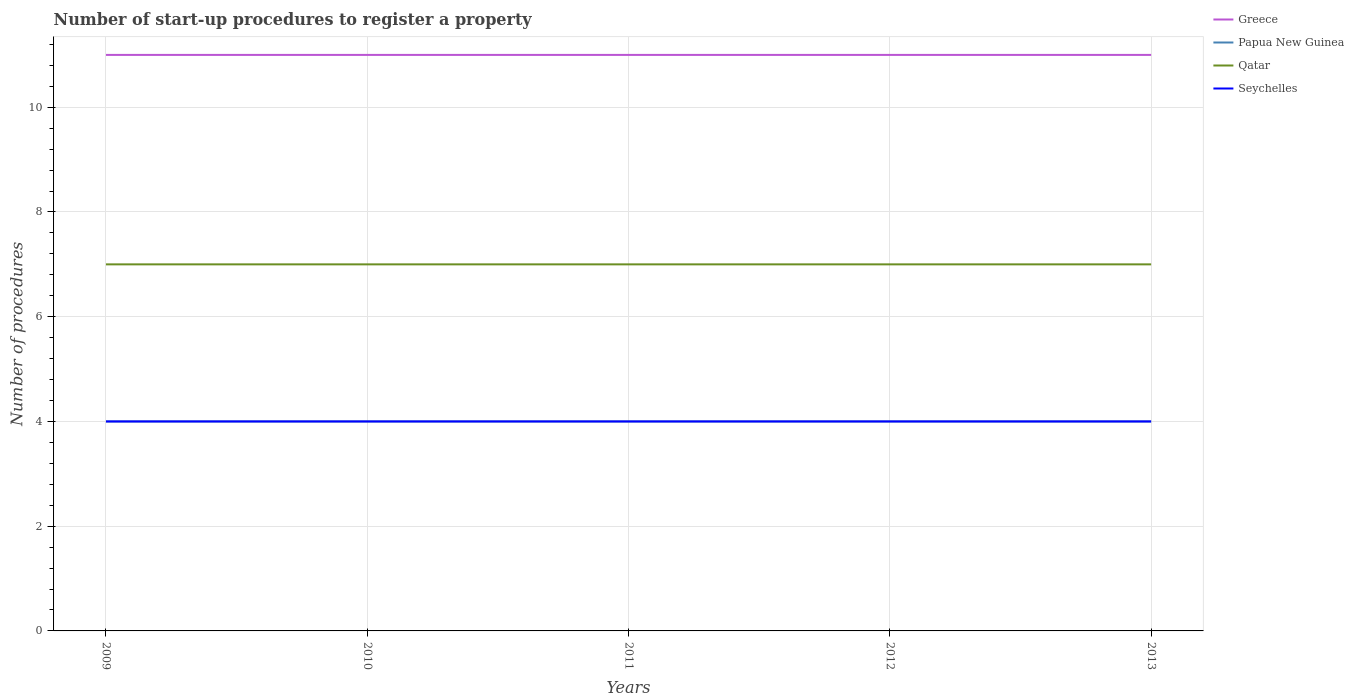Does the line corresponding to Greece intersect with the line corresponding to Seychelles?
Your answer should be very brief. No. Is the number of lines equal to the number of legend labels?
Your response must be concise. Yes. Across all years, what is the maximum number of procedures required to register a property in Papua New Guinea?
Your response must be concise. 4. In which year was the number of procedures required to register a property in Greece maximum?
Your answer should be very brief. 2009. What is the difference between the highest and the second highest number of procedures required to register a property in Seychelles?
Your answer should be very brief. 0. What is the difference between the highest and the lowest number of procedures required to register a property in Papua New Guinea?
Your answer should be very brief. 0. Is the number of procedures required to register a property in Seychelles strictly greater than the number of procedures required to register a property in Greece over the years?
Offer a terse response. Yes. How many lines are there?
Give a very brief answer. 4. How many years are there in the graph?
Your answer should be very brief. 5. What is the difference between two consecutive major ticks on the Y-axis?
Ensure brevity in your answer.  2. Are the values on the major ticks of Y-axis written in scientific E-notation?
Give a very brief answer. No. Where does the legend appear in the graph?
Make the answer very short. Top right. How many legend labels are there?
Your answer should be compact. 4. How are the legend labels stacked?
Offer a terse response. Vertical. What is the title of the graph?
Your answer should be very brief. Number of start-up procedures to register a property. What is the label or title of the X-axis?
Ensure brevity in your answer.  Years. What is the label or title of the Y-axis?
Provide a short and direct response. Number of procedures. What is the Number of procedures of Greece in 2009?
Make the answer very short. 11. What is the Number of procedures of Papua New Guinea in 2009?
Offer a terse response. 4. What is the Number of procedures in Seychelles in 2009?
Offer a terse response. 4. What is the Number of procedures in Qatar in 2010?
Keep it short and to the point. 7. What is the Number of procedures of Greece in 2011?
Provide a succinct answer. 11. What is the Number of procedures in Qatar in 2011?
Your answer should be very brief. 7. What is the Number of procedures in Seychelles in 2011?
Ensure brevity in your answer.  4. What is the Number of procedures in Papua New Guinea in 2012?
Offer a very short reply. 4. What is the Number of procedures in Seychelles in 2012?
Offer a very short reply. 4. What is the Number of procedures of Greece in 2013?
Your answer should be compact. 11. What is the Number of procedures of Qatar in 2013?
Your response must be concise. 7. Across all years, what is the maximum Number of procedures in Greece?
Make the answer very short. 11. Across all years, what is the maximum Number of procedures in Qatar?
Keep it short and to the point. 7. What is the total Number of procedures in Papua New Guinea in the graph?
Offer a very short reply. 20. What is the total Number of procedures in Qatar in the graph?
Offer a very short reply. 35. What is the difference between the Number of procedures of Greece in 2009 and that in 2010?
Offer a terse response. 0. What is the difference between the Number of procedures of Papua New Guinea in 2009 and that in 2010?
Ensure brevity in your answer.  0. What is the difference between the Number of procedures in Seychelles in 2009 and that in 2010?
Offer a terse response. 0. What is the difference between the Number of procedures of Greece in 2009 and that in 2011?
Give a very brief answer. 0. What is the difference between the Number of procedures in Qatar in 2009 and that in 2011?
Your answer should be compact. 0. What is the difference between the Number of procedures of Seychelles in 2009 and that in 2011?
Ensure brevity in your answer.  0. What is the difference between the Number of procedures of Qatar in 2009 and that in 2012?
Offer a very short reply. 0. What is the difference between the Number of procedures in Greece in 2009 and that in 2013?
Make the answer very short. 0. What is the difference between the Number of procedures in Papua New Guinea in 2009 and that in 2013?
Offer a terse response. 0. What is the difference between the Number of procedures of Qatar in 2010 and that in 2011?
Your response must be concise. 0. What is the difference between the Number of procedures in Seychelles in 2010 and that in 2011?
Provide a short and direct response. 0. What is the difference between the Number of procedures in Greece in 2010 and that in 2012?
Your answer should be very brief. 0. What is the difference between the Number of procedures in Papua New Guinea in 2010 and that in 2012?
Make the answer very short. 0. What is the difference between the Number of procedures in Qatar in 2010 and that in 2012?
Ensure brevity in your answer.  0. What is the difference between the Number of procedures in Seychelles in 2010 and that in 2012?
Offer a very short reply. 0. What is the difference between the Number of procedures in Qatar in 2010 and that in 2013?
Your answer should be very brief. 0. What is the difference between the Number of procedures of Seychelles in 2010 and that in 2013?
Your answer should be compact. 0. What is the difference between the Number of procedures in Papua New Guinea in 2011 and that in 2012?
Provide a succinct answer. 0. What is the difference between the Number of procedures of Qatar in 2011 and that in 2012?
Your response must be concise. 0. What is the difference between the Number of procedures of Seychelles in 2011 and that in 2012?
Provide a succinct answer. 0. What is the difference between the Number of procedures in Qatar in 2011 and that in 2013?
Give a very brief answer. 0. What is the difference between the Number of procedures in Papua New Guinea in 2012 and that in 2013?
Provide a succinct answer. 0. What is the difference between the Number of procedures in Greece in 2009 and the Number of procedures in Papua New Guinea in 2010?
Give a very brief answer. 7. What is the difference between the Number of procedures of Greece in 2009 and the Number of procedures of Qatar in 2010?
Make the answer very short. 4. What is the difference between the Number of procedures of Papua New Guinea in 2009 and the Number of procedures of Seychelles in 2010?
Offer a very short reply. 0. What is the difference between the Number of procedures in Greece in 2009 and the Number of procedures in Qatar in 2011?
Provide a succinct answer. 4. What is the difference between the Number of procedures of Qatar in 2009 and the Number of procedures of Seychelles in 2011?
Offer a terse response. 3. What is the difference between the Number of procedures of Greece in 2009 and the Number of procedures of Qatar in 2012?
Provide a succinct answer. 4. What is the difference between the Number of procedures in Papua New Guinea in 2009 and the Number of procedures in Seychelles in 2012?
Your response must be concise. 0. What is the difference between the Number of procedures in Qatar in 2009 and the Number of procedures in Seychelles in 2012?
Make the answer very short. 3. What is the difference between the Number of procedures in Greece in 2010 and the Number of procedures in Papua New Guinea in 2011?
Your answer should be compact. 7. What is the difference between the Number of procedures of Papua New Guinea in 2010 and the Number of procedures of Qatar in 2011?
Your answer should be compact. -3. What is the difference between the Number of procedures of Qatar in 2010 and the Number of procedures of Seychelles in 2011?
Your answer should be very brief. 3. What is the difference between the Number of procedures of Greece in 2010 and the Number of procedures of Papua New Guinea in 2012?
Keep it short and to the point. 7. What is the difference between the Number of procedures in Greece in 2010 and the Number of procedures in Seychelles in 2012?
Make the answer very short. 7. What is the difference between the Number of procedures of Papua New Guinea in 2010 and the Number of procedures of Qatar in 2012?
Offer a terse response. -3. What is the difference between the Number of procedures in Greece in 2010 and the Number of procedures in Papua New Guinea in 2013?
Provide a succinct answer. 7. What is the difference between the Number of procedures of Greece in 2010 and the Number of procedures of Qatar in 2013?
Offer a very short reply. 4. What is the difference between the Number of procedures of Greece in 2010 and the Number of procedures of Seychelles in 2013?
Your answer should be very brief. 7. What is the difference between the Number of procedures in Greece in 2011 and the Number of procedures in Qatar in 2012?
Give a very brief answer. 4. What is the difference between the Number of procedures in Greece in 2011 and the Number of procedures in Seychelles in 2012?
Your answer should be compact. 7. What is the difference between the Number of procedures in Papua New Guinea in 2011 and the Number of procedures in Qatar in 2012?
Offer a very short reply. -3. What is the difference between the Number of procedures of Qatar in 2011 and the Number of procedures of Seychelles in 2012?
Your answer should be compact. 3. What is the difference between the Number of procedures of Greece in 2011 and the Number of procedures of Papua New Guinea in 2013?
Ensure brevity in your answer.  7. What is the difference between the Number of procedures of Papua New Guinea in 2011 and the Number of procedures of Qatar in 2013?
Make the answer very short. -3. What is the difference between the Number of procedures of Papua New Guinea in 2011 and the Number of procedures of Seychelles in 2013?
Ensure brevity in your answer.  0. What is the difference between the Number of procedures of Qatar in 2011 and the Number of procedures of Seychelles in 2013?
Offer a terse response. 3. What is the difference between the Number of procedures in Greece in 2012 and the Number of procedures in Qatar in 2013?
Make the answer very short. 4. What is the difference between the Number of procedures in Greece in 2012 and the Number of procedures in Seychelles in 2013?
Give a very brief answer. 7. What is the difference between the Number of procedures in Qatar in 2012 and the Number of procedures in Seychelles in 2013?
Make the answer very short. 3. What is the average Number of procedures in Papua New Guinea per year?
Ensure brevity in your answer.  4. What is the average Number of procedures of Seychelles per year?
Your answer should be very brief. 4. In the year 2009, what is the difference between the Number of procedures of Greece and Number of procedures of Papua New Guinea?
Provide a succinct answer. 7. In the year 2009, what is the difference between the Number of procedures in Greece and Number of procedures in Qatar?
Your answer should be compact. 4. In the year 2009, what is the difference between the Number of procedures of Greece and Number of procedures of Seychelles?
Provide a short and direct response. 7. In the year 2009, what is the difference between the Number of procedures of Papua New Guinea and Number of procedures of Qatar?
Provide a short and direct response. -3. In the year 2009, what is the difference between the Number of procedures in Papua New Guinea and Number of procedures in Seychelles?
Your response must be concise. 0. In the year 2010, what is the difference between the Number of procedures of Greece and Number of procedures of Papua New Guinea?
Your answer should be compact. 7. In the year 2010, what is the difference between the Number of procedures of Greece and Number of procedures of Seychelles?
Give a very brief answer. 7. In the year 2010, what is the difference between the Number of procedures in Papua New Guinea and Number of procedures in Qatar?
Provide a succinct answer. -3. In the year 2010, what is the difference between the Number of procedures of Qatar and Number of procedures of Seychelles?
Your answer should be very brief. 3. In the year 2011, what is the difference between the Number of procedures of Greece and Number of procedures of Seychelles?
Ensure brevity in your answer.  7. In the year 2011, what is the difference between the Number of procedures of Papua New Guinea and Number of procedures of Seychelles?
Your answer should be compact. 0. In the year 2012, what is the difference between the Number of procedures of Greece and Number of procedures of Papua New Guinea?
Your response must be concise. 7. In the year 2012, what is the difference between the Number of procedures in Greece and Number of procedures in Qatar?
Offer a terse response. 4. In the year 2012, what is the difference between the Number of procedures in Papua New Guinea and Number of procedures in Seychelles?
Give a very brief answer. 0. In the year 2013, what is the difference between the Number of procedures in Greece and Number of procedures in Papua New Guinea?
Keep it short and to the point. 7. In the year 2013, what is the difference between the Number of procedures of Papua New Guinea and Number of procedures of Seychelles?
Your response must be concise. 0. What is the ratio of the Number of procedures in Papua New Guinea in 2009 to that in 2010?
Offer a very short reply. 1. What is the ratio of the Number of procedures of Seychelles in 2009 to that in 2010?
Offer a terse response. 1. What is the ratio of the Number of procedures in Papua New Guinea in 2009 to that in 2012?
Your answer should be very brief. 1. What is the ratio of the Number of procedures in Qatar in 2009 to that in 2012?
Keep it short and to the point. 1. What is the ratio of the Number of procedures in Seychelles in 2009 to that in 2012?
Your answer should be compact. 1. What is the ratio of the Number of procedures in Papua New Guinea in 2009 to that in 2013?
Ensure brevity in your answer.  1. What is the ratio of the Number of procedures of Papua New Guinea in 2010 to that in 2011?
Offer a very short reply. 1. What is the ratio of the Number of procedures in Qatar in 2010 to that in 2011?
Keep it short and to the point. 1. What is the ratio of the Number of procedures in Greece in 2010 to that in 2012?
Provide a succinct answer. 1. What is the ratio of the Number of procedures of Papua New Guinea in 2010 to that in 2013?
Offer a very short reply. 1. What is the ratio of the Number of procedures in Papua New Guinea in 2011 to that in 2012?
Ensure brevity in your answer.  1. What is the ratio of the Number of procedures in Qatar in 2011 to that in 2012?
Your response must be concise. 1. What is the ratio of the Number of procedures in Seychelles in 2011 to that in 2012?
Your response must be concise. 1. What is the ratio of the Number of procedures of Qatar in 2011 to that in 2013?
Your answer should be very brief. 1. What is the ratio of the Number of procedures of Seychelles in 2011 to that in 2013?
Provide a short and direct response. 1. What is the ratio of the Number of procedures of Greece in 2012 to that in 2013?
Make the answer very short. 1. What is the ratio of the Number of procedures in Papua New Guinea in 2012 to that in 2013?
Give a very brief answer. 1. What is the ratio of the Number of procedures in Qatar in 2012 to that in 2013?
Provide a succinct answer. 1. What is the difference between the highest and the second highest Number of procedures of Seychelles?
Keep it short and to the point. 0. 